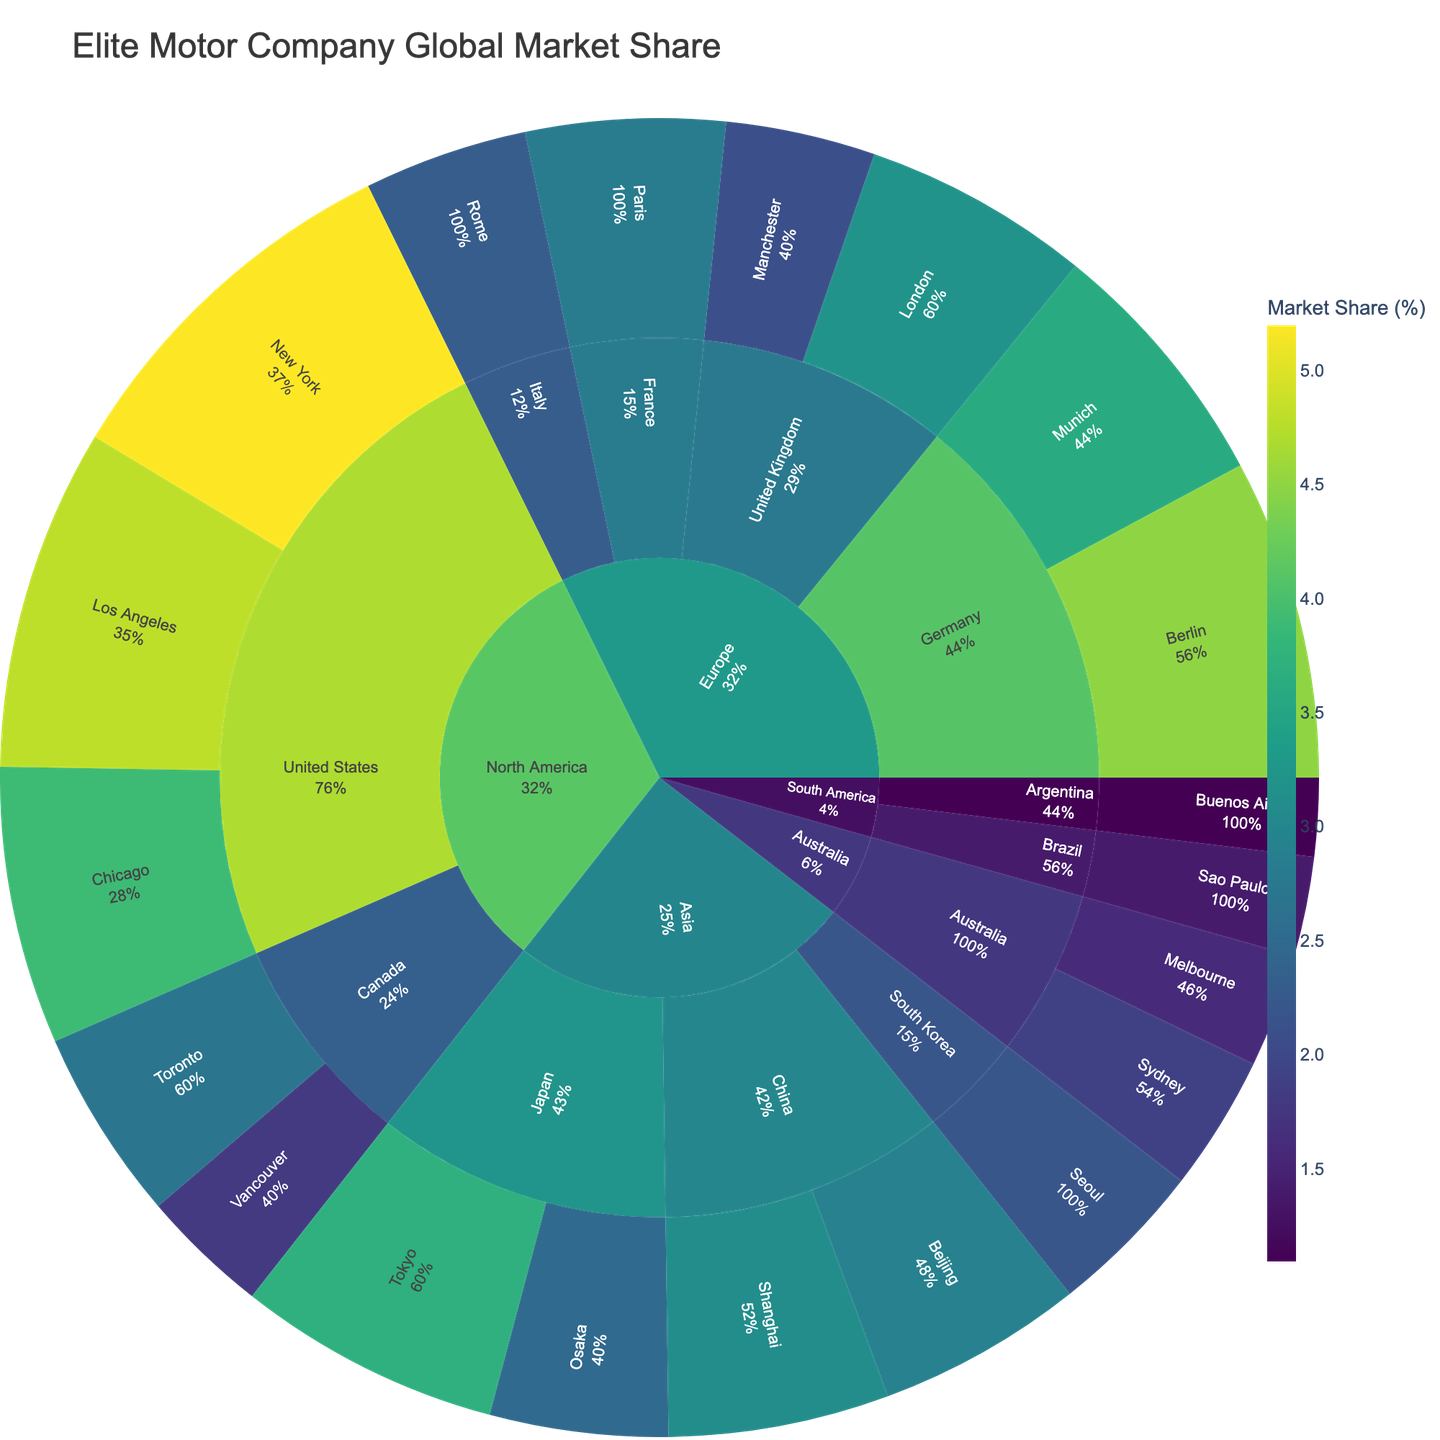what is the total market share of Elite Motor Company in Europe? First, identify the market share in each European city: Berlin (4.5), Munich (3.6), London (3.2), Manchester (2.1), Paris (2.8), and Rome (2.3). Add these values together: 4.5 + 3.6 + 3.2 + 2.1 + 2.8 + 2.3 = 18.5.
Answer: 18.5% Which city in North America has the highest market share? Look within the North American cities: New York (5.2), Los Angeles (4.8), Chicago (3.9), Toronto (2.7), and Vancouver (1.8). The highest value is 5.2, which belongs to New York.
Answer: New York What is the combined market share of Tokyo and Osaka in Japan? The market shares for Tokyo and Osaka are 3.7 and 2.5 respectively. Add these values together: 3.7 + 2.5 = 6.2.
Answer: 6.2% How does Los Angeles's market share compare to Chicago's? Los Angeles has a market share of 4.8, while Chicago has 3.9. Los Angeles's market share is greater than Chicago's.
Answer: Los Angeles has a higher market share What is the market share difference between the United States and Canada? First, sum the market share of all cities in the United States: New York (5.2), Los Angeles (4.8), Chicago (3.9) which totals to 13.9. For Canada, sum Toronto (2.7) and Vancouver (1.8) which totals to 4.5. Subtract Canada's total market share from the United States' total market share: 13.9 - 4.5 = 9.4.
Answer: 9.4% Which city in Australia has a higher market share? Sydney has a market share of 1.9, while Melbourne has 1.6. Sydney has a higher market share.
Answer: Sydney What is the overall market share of Elite Motor Company in South America? Sum the market shares of Sao Paulo (1.4) and Buenos Aires (1.1): 1.4 + 1.1 = 2.5.
Answer: 2.5% How many regions are represented in the global market share breakdown? Identify the unique regions listed: North America, Europe, Asia, Australia, and South America. There are 5 regions in total.
Answer: 5 regions What percentage of the total market share does the city of Tokyo hold? The market share of Tokyo is 3.7. To find the percentage of the total market share, first find the total market share by summing all cities' market shares (5.2+4.8+3.9+2.7+1.8+4.5+3.6+3.2+2.1+2.8+2.3+3.7+2.5+3.1+2.9+2.2+1.9+1.6+1.4+1.1 = 55.2). The percentage is calculated as (Tokyo's market share / total market share) * 100: (3.7 / 55.2) * 100 ≈ 6.7.
Answer: 6.7% Which city in China has a greater market share? Shanghai has a market share of 3.1, while Beijing has 2.9. Shanghai has a greater market share.
Answer: Shanghai 